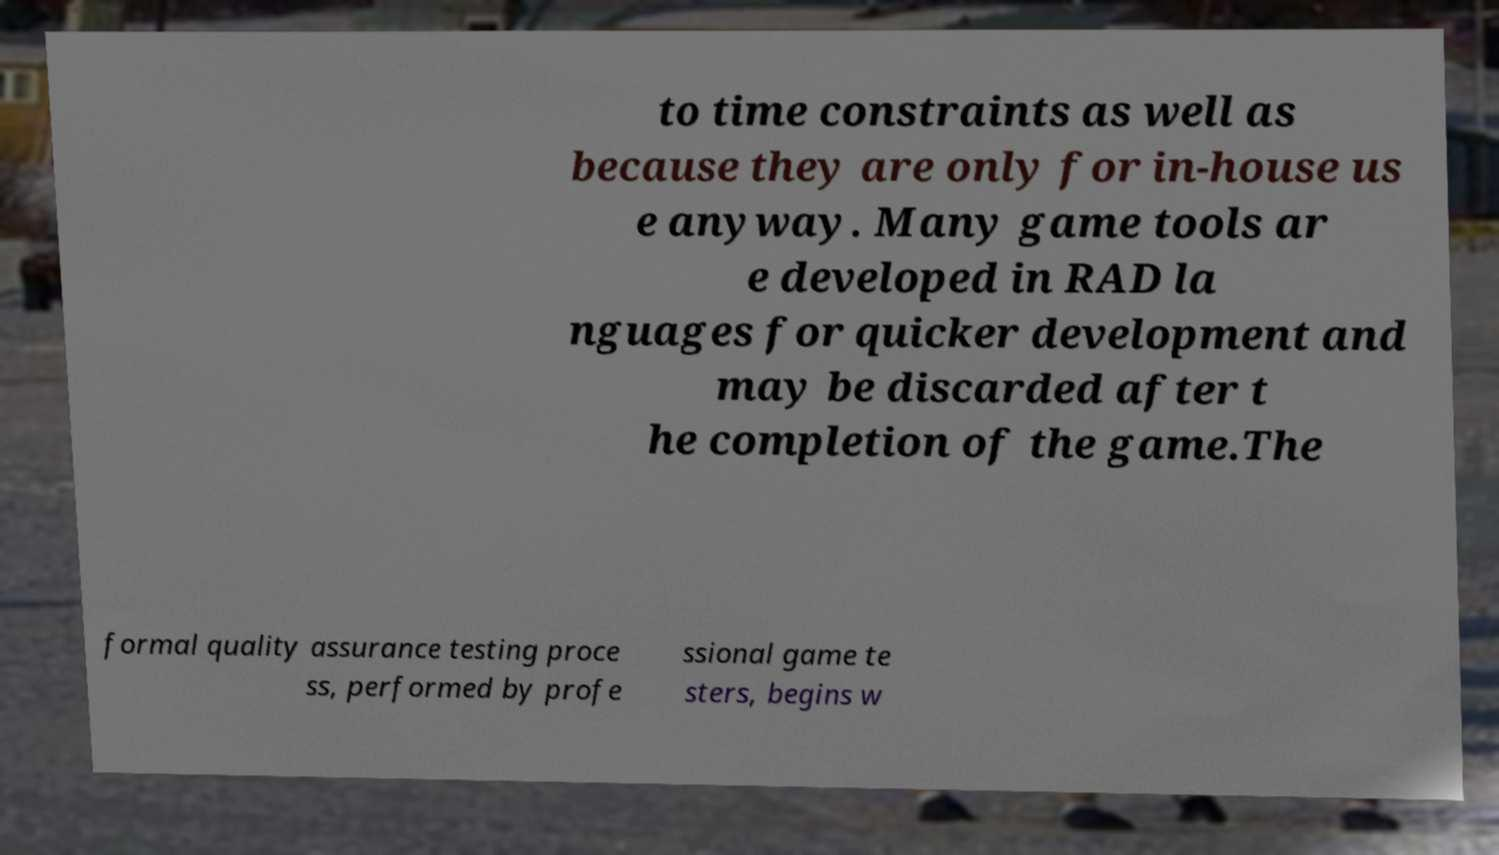What messages or text are displayed in this image? I need them in a readable, typed format. to time constraints as well as because they are only for in-house us e anyway. Many game tools ar e developed in RAD la nguages for quicker development and may be discarded after t he completion of the game.The formal quality assurance testing proce ss, performed by profe ssional game te sters, begins w 